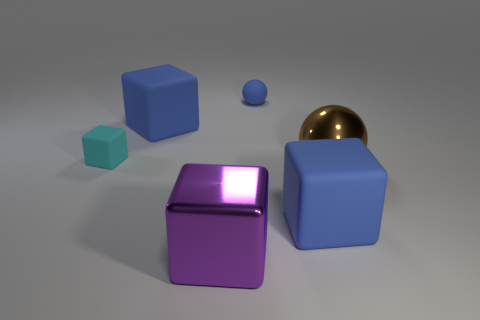Subtract all tiny matte cubes. How many cubes are left? 3 Subtract all red cylinders. How many blue blocks are left? 2 Subtract all purple cubes. How many cubes are left? 3 Add 2 large brown metal balls. How many objects exist? 8 Subtract all blocks. How many objects are left? 2 Subtract 0 red cylinders. How many objects are left? 6 Subtract all green spheres. Subtract all green cubes. How many spheres are left? 2 Subtract all blue matte things. Subtract all blue things. How many objects are left? 0 Add 2 spheres. How many spheres are left? 4 Add 1 small blue rubber objects. How many small blue rubber objects exist? 2 